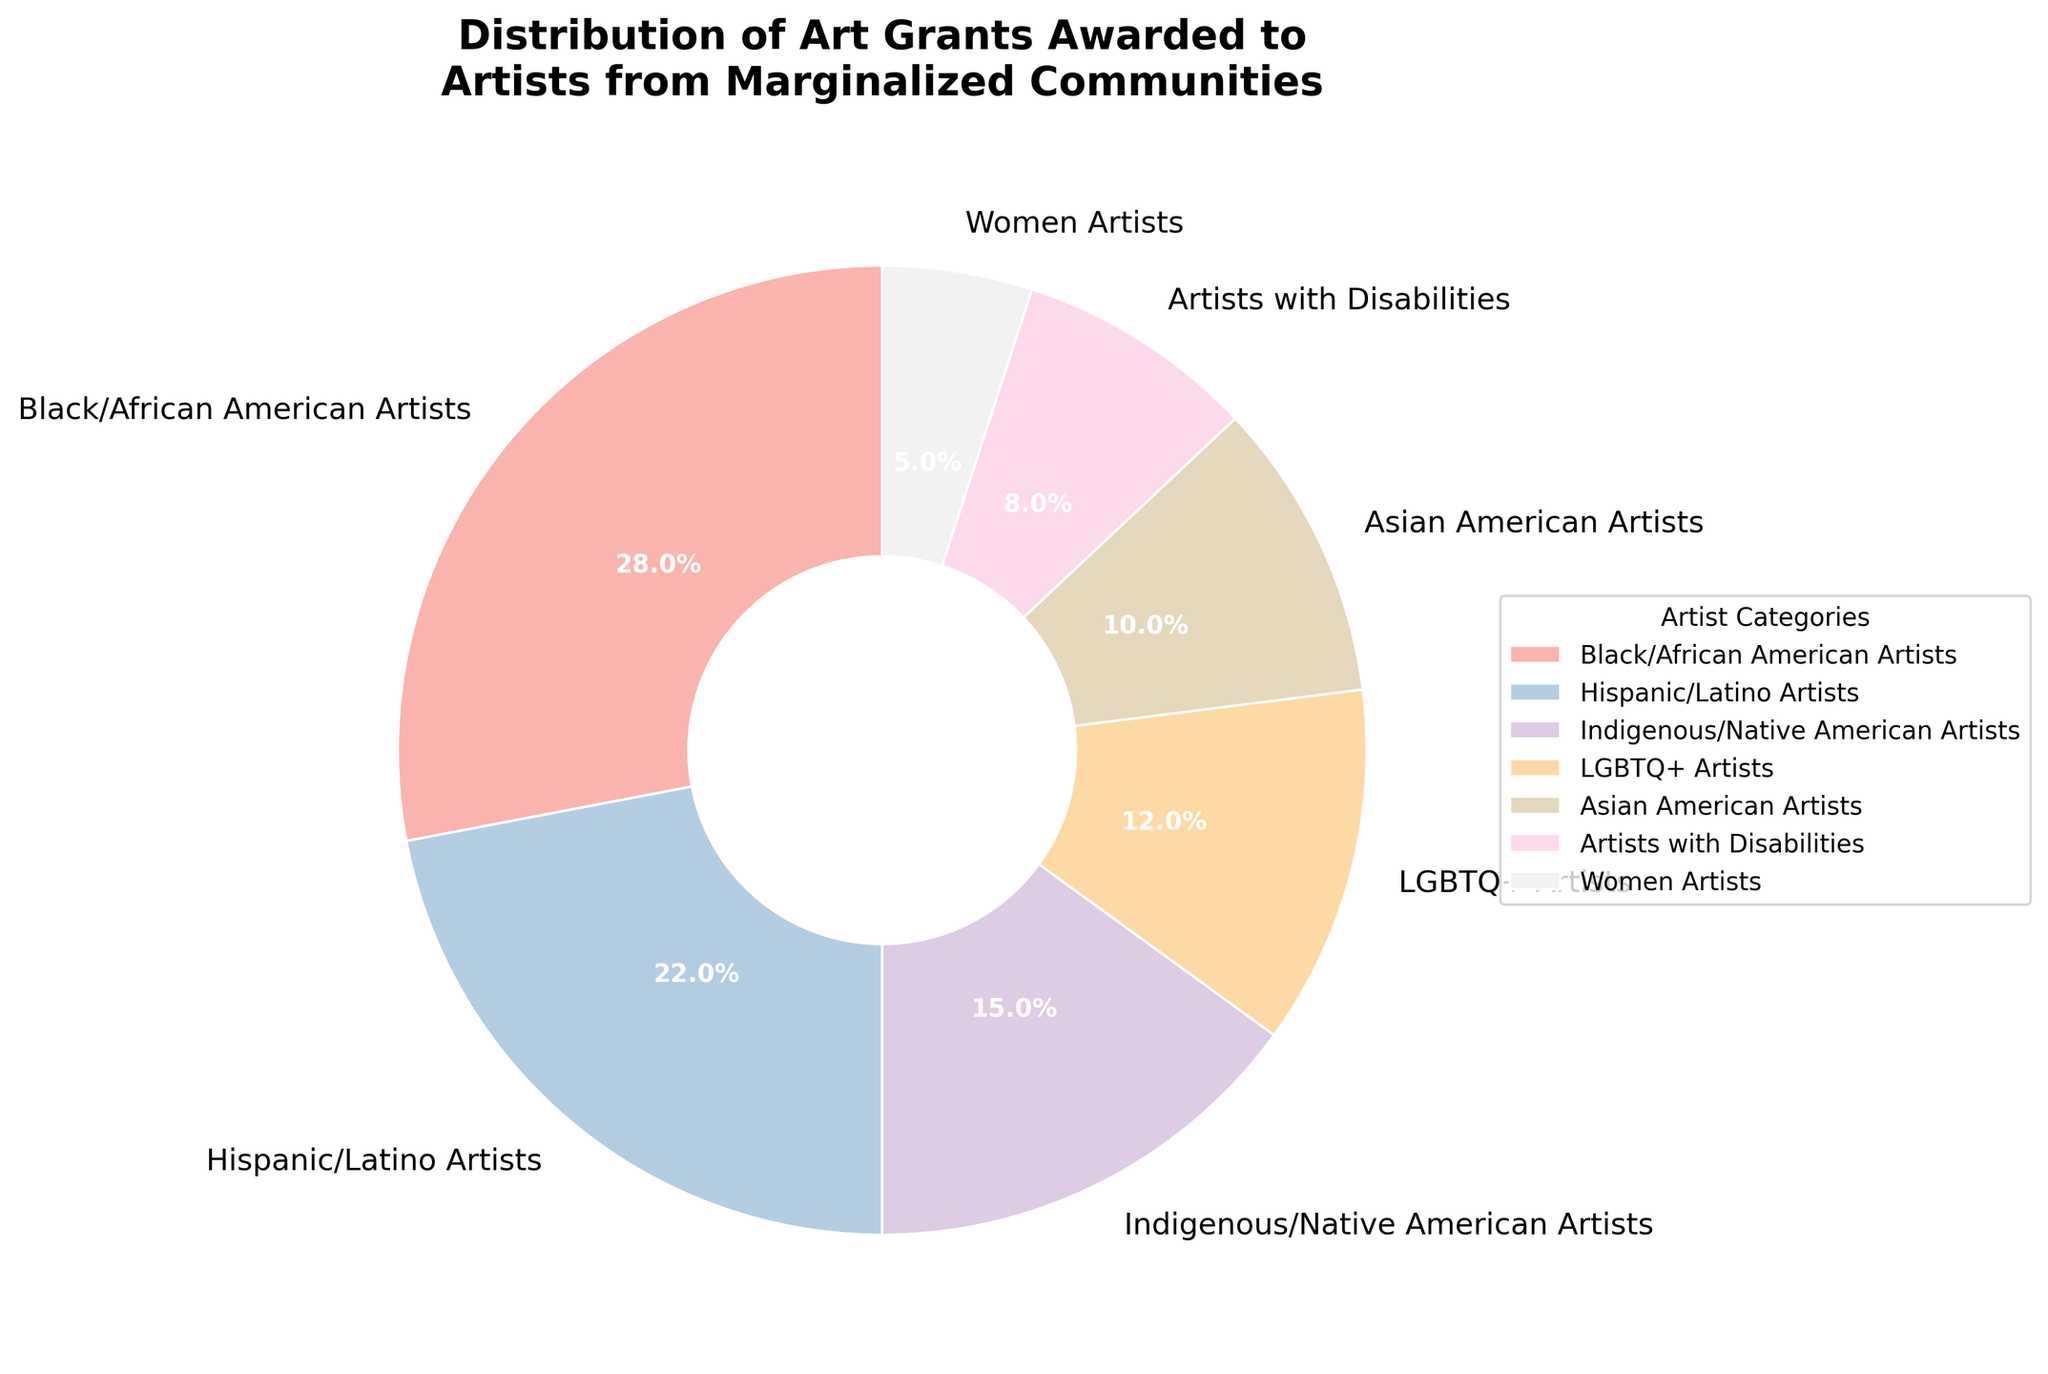Which artist category received the highest percentage of art grants? The highest percentage visible on the pie chart is 28%, which corresponds to Black/African American Artists.
Answer: Black/African American Artists What is the combined percentage of art grants awarded to Indigenous/Native American Artists and Artists with Disabilities? Adding the percentages for Indigenous/Native American Artists (15%) and Artists with Disabilities (8%) gives 15 + 8 = 23%.
Answer: 23% Are art grants awarded to Hispanic/Latino Artists higher or lower compared to LGBTQ+ Artists? Comparing the percentages for Hispanic/Latino Artists (22%) with LGBTQ+ Artists (12%), 22% is higher than 12%.
Answer: Higher What is the difference in grant percentages between Women Artists and Artists with Disabilities? Subtracting the percentage for Women Artists (5%) from Artists with Disabilities (8%) gives 8 - 5 = 3%.
Answer: 3% If you combine the percentages of Asian American Artists and Women Artists, will it surpass 15%? Adding the percentages for Asian American Artists (10%) and Women Artists (5%) gives 10 + 5 = 15%, which does not surpass 15%.
Answer: No Which category received the smallest percentage of art grants? The smallest percentage visible on the pie chart is 5%, which corresponds to Women Artists.
Answer: Women Artists What visual feature highlights the distribution of grants among different artist categories? The legend beside the pie chart shows the distribution labels with their corresponding colors, and segments in varying sizes on the pie chart represent different percentages.
Answer: Legend and segment sizes Do the combined percentages for Black/African American Artists and Hispanic/Latino Artists make up more than half of the total grants? Adding the percentages for Black/African American Artists (28%) and Hispanic/Latino Artists (22%) gives 28 + 22 = 50%, which equals half of the total grants.
Answer: No How does the grant distribution for Black/African American Artists compare to Hispanic/Latino Artists? The percentage for Black/African American Artists (28%) is higher compared to Hispanic/Latino Artists (22%).
Answer: Higher 